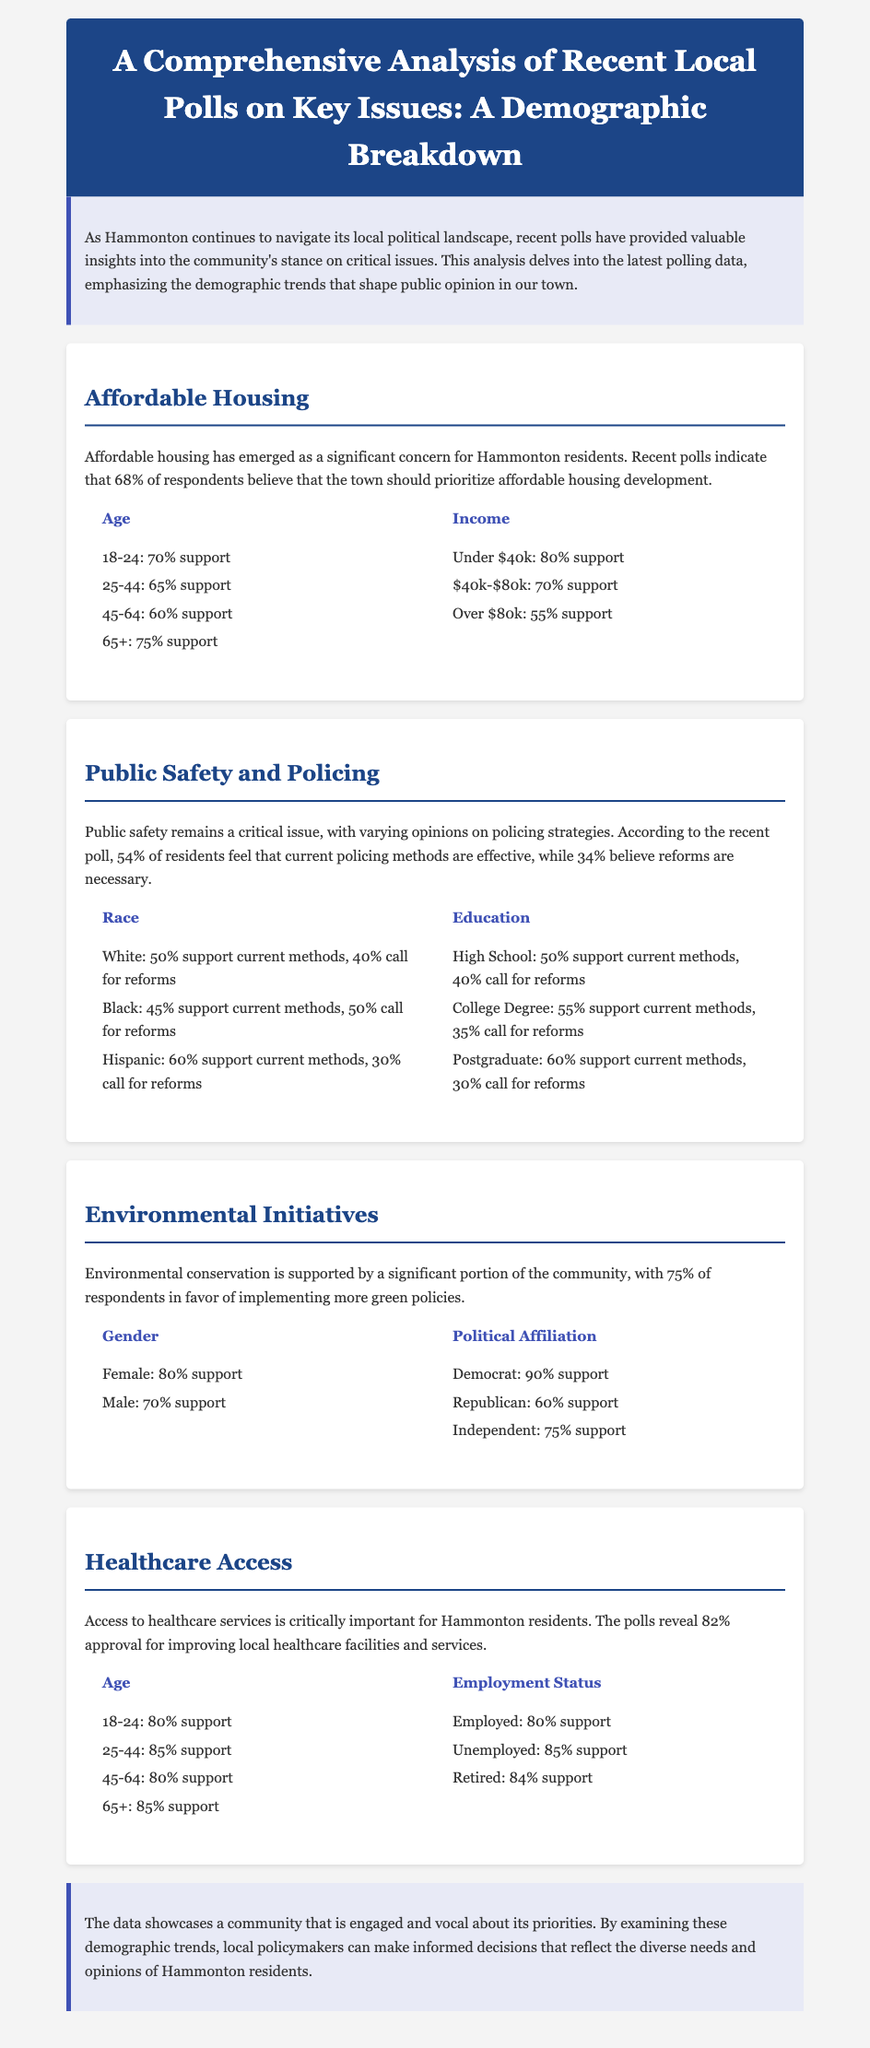What percentage of residents support affordable housing development? The document states that 68% of respondents believe the town should prioritize affordable housing development.
Answer: 68% What is the majority opinion about current policing methods among Black residents? The document notes that 45% of Black residents support current methods, while 50% call for reforms.
Answer: 45% Which age group shows the highest support for improving local healthcare facilities? The highest support comes from respondents aged 25-44, with 85% approval for improving healthcare access.
Answer: 85% What percentage of Democrat respondents support environmental initiatives? The document indicates that 90% of Democrat respondents support implementing more green policies.
Answer: 90% How do the views on public safety differ between White and Hispanic respondents? Among White respondents, 50% support current policing methods, while 60% of Hispanic respondents do.
Answer: 50% support current methods (White) vs. 60% support current methods (Hispanic) Which demographic category had the most significant support for affordable housing? Among income demographics, those earning under $40k showed the most considerable support at 80%.
Answer: 80% What is the support level for environmental initiatives among Independent voters? The document states that 75% of Independent voters support environmental initiatives.
Answer: 75% Which group has the lowest support for healthcare improvement? The demographic with the lowest reported support for improving healthcare facilities is those with an income over $80k, at 55%.
Answer: 55% What is the conclusion of the document about community engagement? The conclusion emphasizes that the data showcases a community engaged and vocal about its priorities.
Answer: Engaged and vocal 